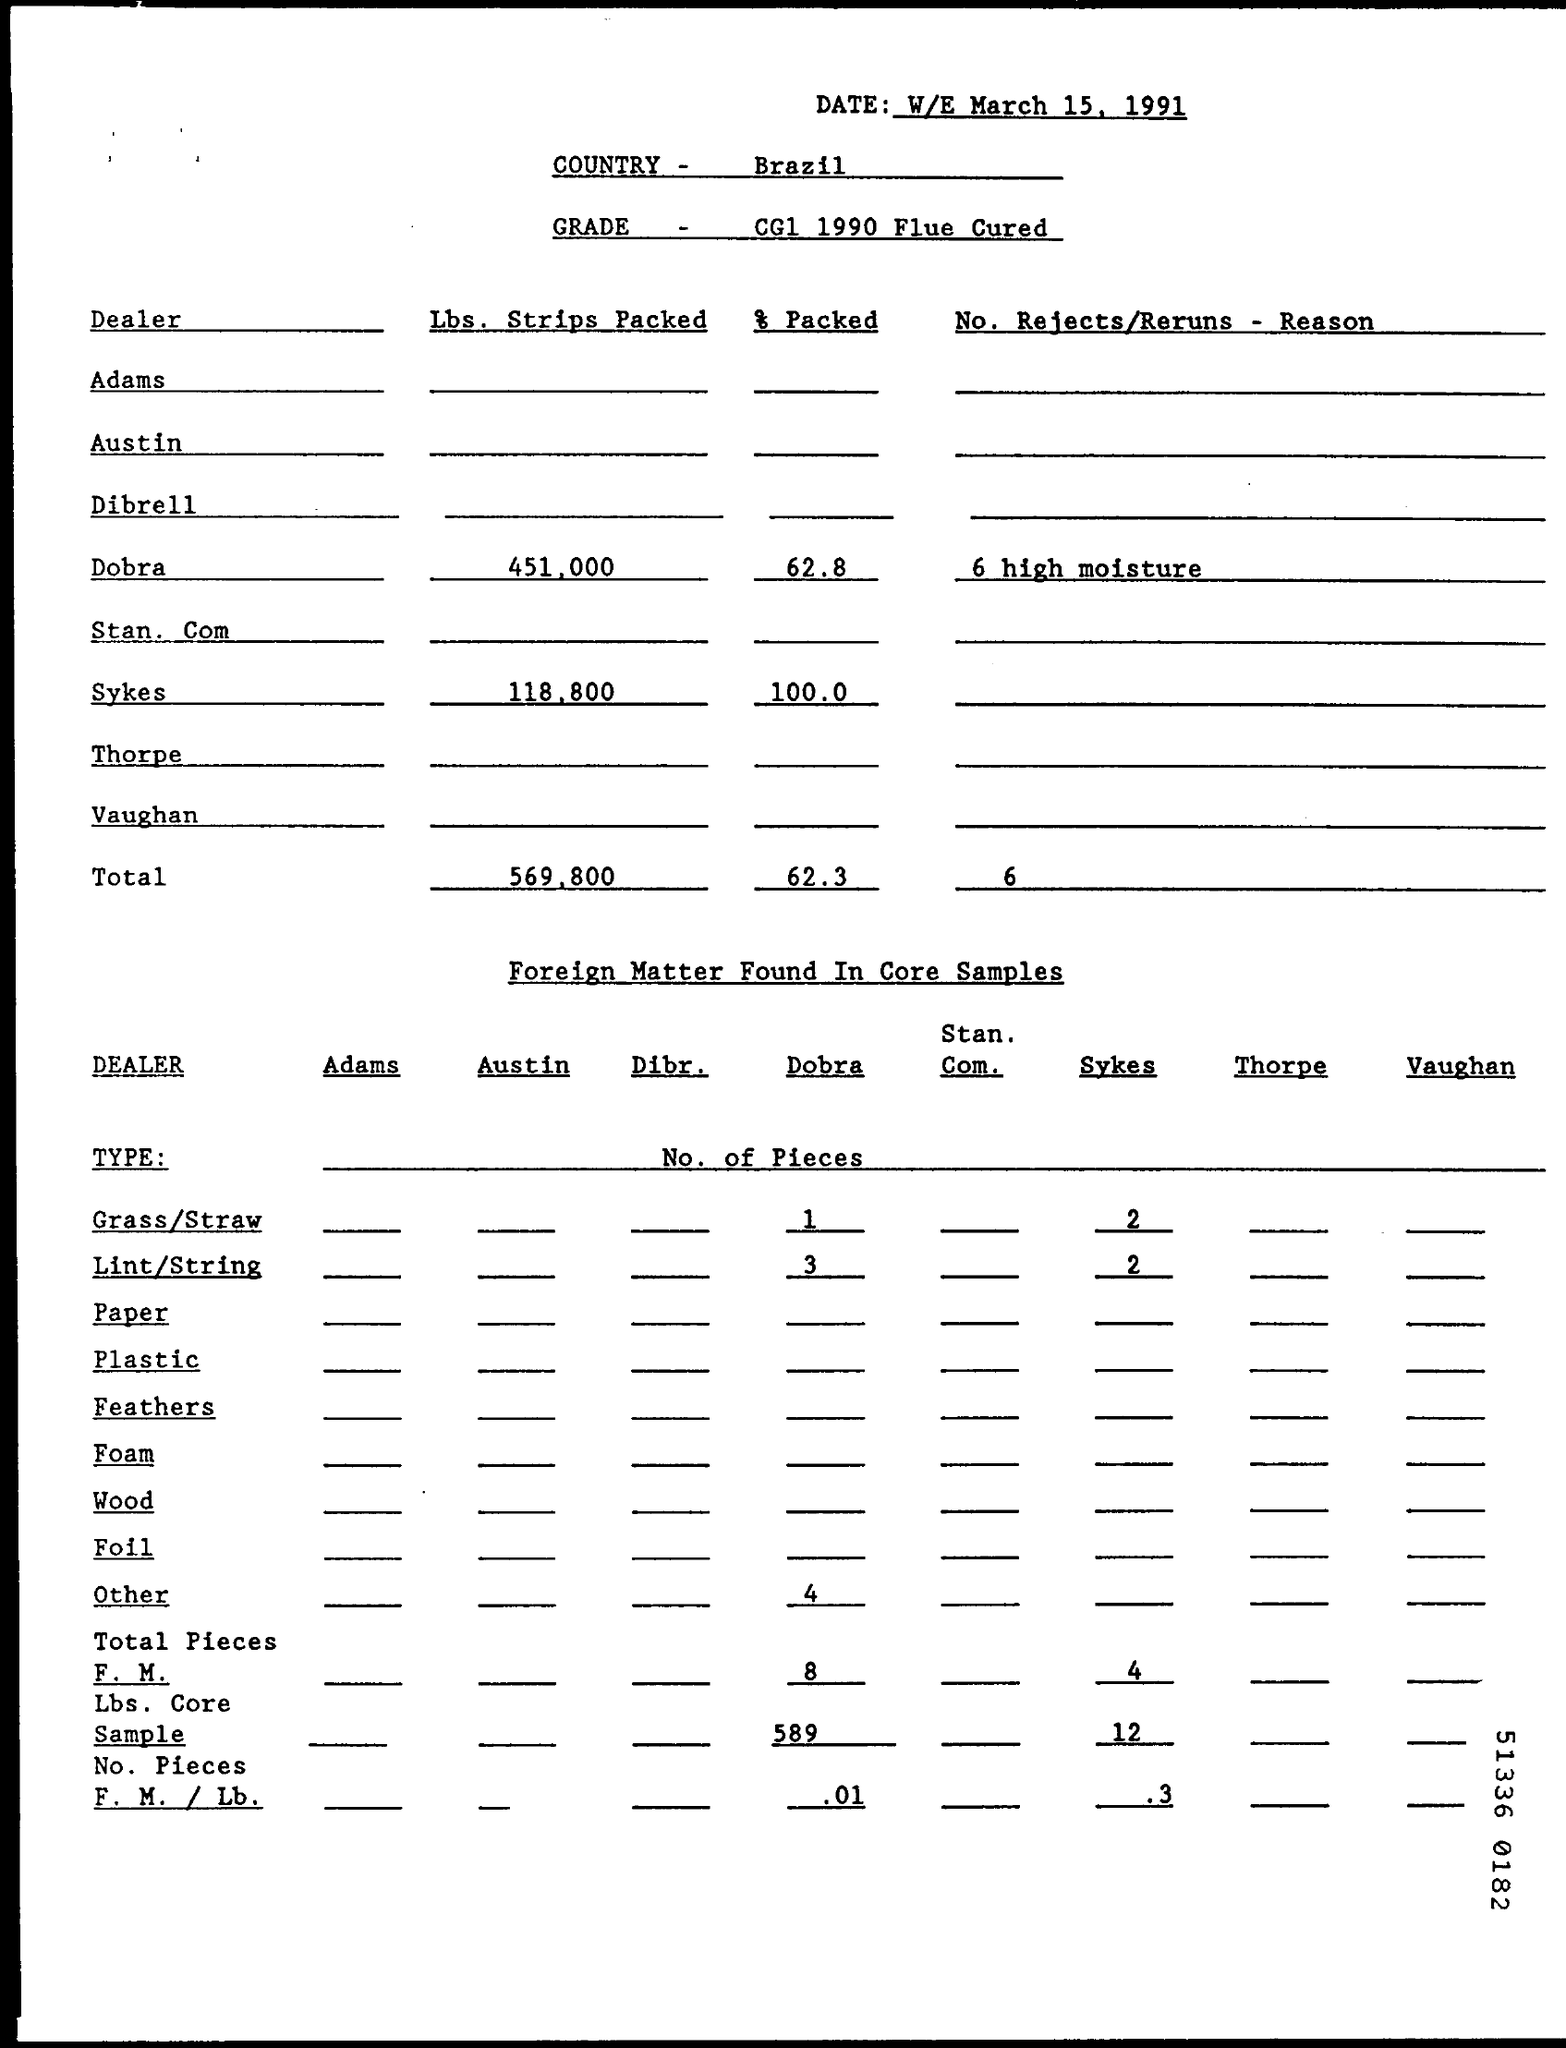What information is given regarding the percentage packed? The document records the percentage of strips packed by two dealers: Dobra and Sykes. Dobra has packed 62.8% of its strips, whereas Sykes has a 100% packing rate, as per the data in the report from March 15, 1991.  Could you detail the materials categorized as 'foreign matter' in this image? Certainly. 'Foreign matter' in the core samples includes grass/straw, lint/string, paper, plastic, feathers, foam, wood, foil, and other unspecified materials which are not typically part of tobacco products. In this report, lint/string seems to be the most common form of foreign matter found. 